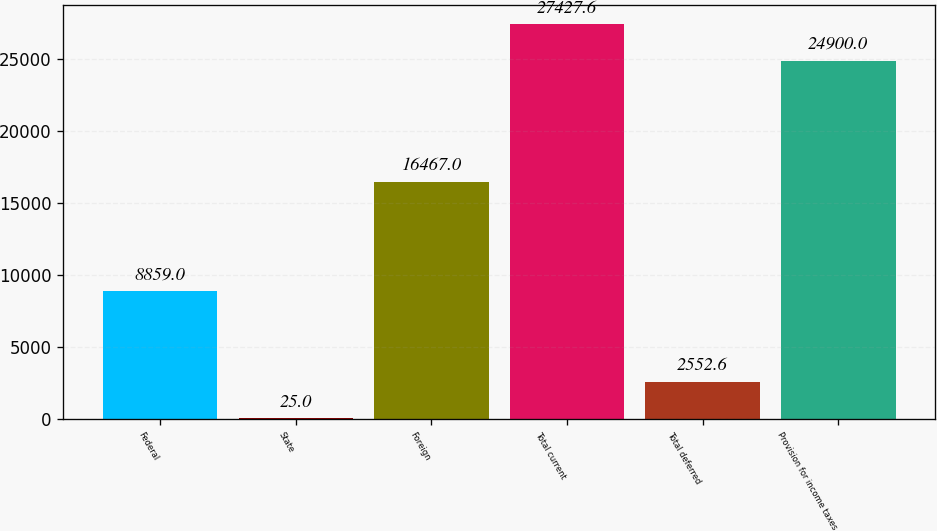Convert chart. <chart><loc_0><loc_0><loc_500><loc_500><bar_chart><fcel>Federal<fcel>State<fcel>Foreign<fcel>Total current<fcel>Total deferred<fcel>Provision for income taxes<nl><fcel>8859<fcel>25<fcel>16467<fcel>27427.6<fcel>2552.6<fcel>24900<nl></chart> 